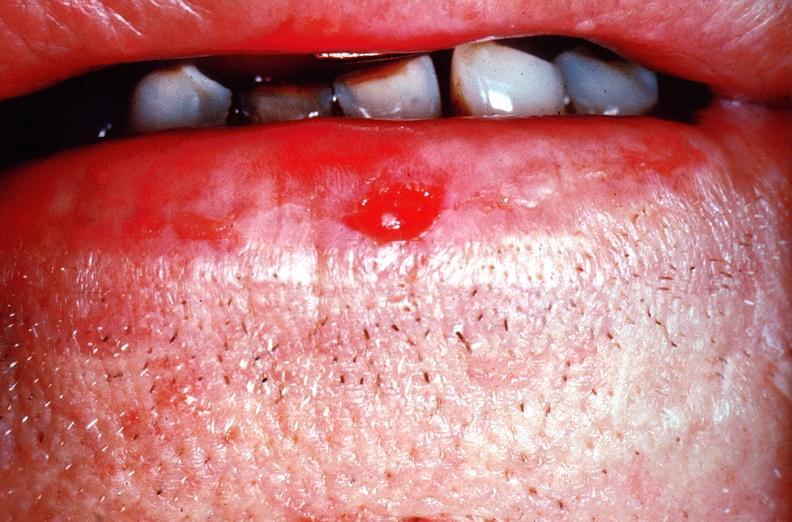does previous slide from this case show squamous cell carcinoma of the lip?
Answer the question using a single word or phrase. No 